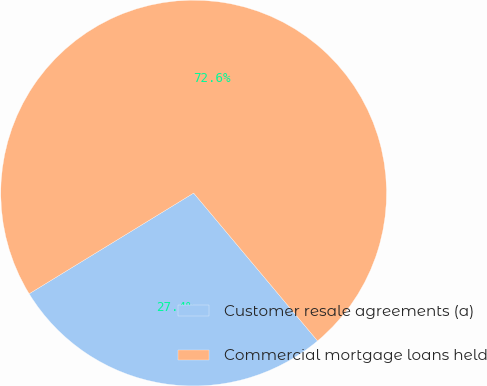<chart> <loc_0><loc_0><loc_500><loc_500><pie_chart><fcel>Customer resale agreements (a)<fcel>Commercial mortgage loans held<nl><fcel>27.36%<fcel>72.64%<nl></chart> 